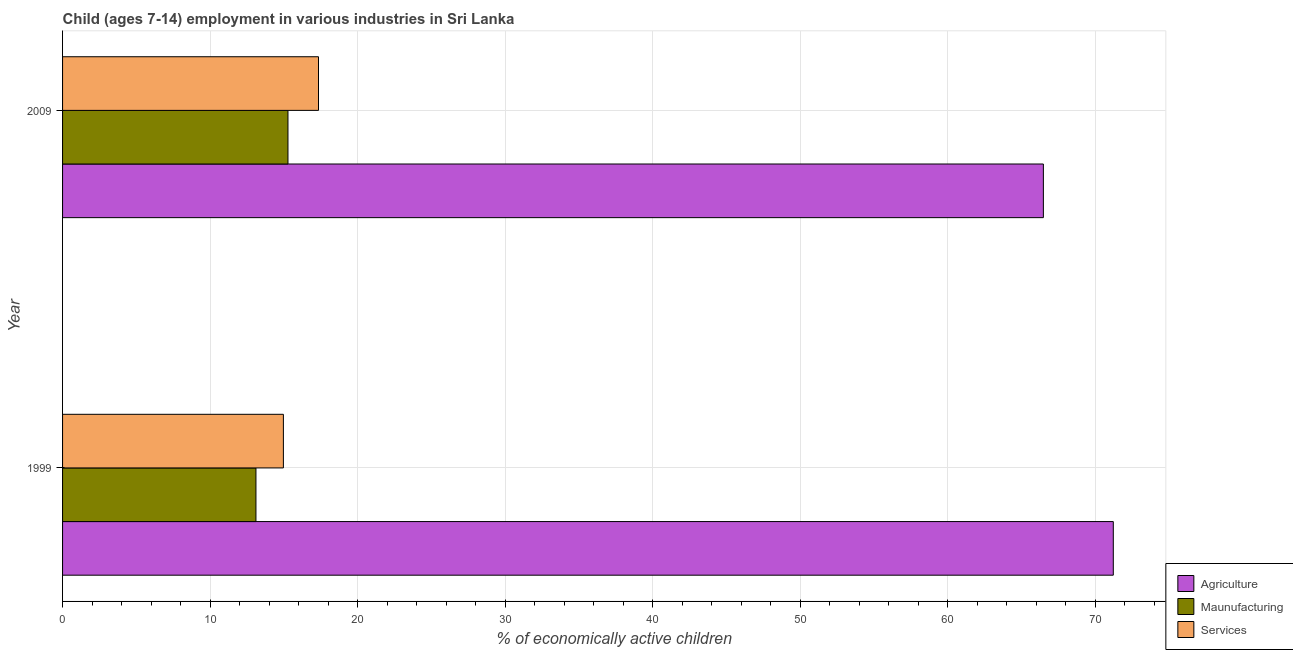Are the number of bars per tick equal to the number of legend labels?
Provide a short and direct response. Yes. How many bars are there on the 2nd tick from the top?
Keep it short and to the point. 3. What is the label of the 2nd group of bars from the top?
Your response must be concise. 1999. In how many cases, is the number of bars for a given year not equal to the number of legend labels?
Provide a short and direct response. 0. What is the percentage of economically active children in manufacturing in 1999?
Give a very brief answer. 13.11. Across all years, what is the maximum percentage of economically active children in agriculture?
Make the answer very short. 71.23. Across all years, what is the minimum percentage of economically active children in agriculture?
Provide a succinct answer. 66.49. In which year was the percentage of economically active children in agriculture minimum?
Offer a very short reply. 2009. What is the total percentage of economically active children in services in the graph?
Give a very brief answer. 32.32. What is the difference between the percentage of economically active children in agriculture in 1999 and that in 2009?
Your answer should be compact. 4.74. What is the difference between the percentage of economically active children in services in 2009 and the percentage of economically active children in agriculture in 1999?
Your answer should be very brief. -53.88. What is the average percentage of economically active children in manufacturing per year?
Your response must be concise. 14.2. In the year 2009, what is the difference between the percentage of economically active children in agriculture and percentage of economically active children in manufacturing?
Your answer should be compact. 51.21. What is the ratio of the percentage of economically active children in agriculture in 1999 to that in 2009?
Your answer should be very brief. 1.07. Is the difference between the percentage of economically active children in manufacturing in 1999 and 2009 greater than the difference between the percentage of economically active children in services in 1999 and 2009?
Offer a very short reply. Yes. In how many years, is the percentage of economically active children in manufacturing greater than the average percentage of economically active children in manufacturing taken over all years?
Make the answer very short. 1. What does the 3rd bar from the top in 1999 represents?
Ensure brevity in your answer.  Agriculture. What does the 3rd bar from the bottom in 1999 represents?
Provide a short and direct response. Services. How many years are there in the graph?
Give a very brief answer. 2. What is the difference between two consecutive major ticks on the X-axis?
Provide a short and direct response. 10. Are the values on the major ticks of X-axis written in scientific E-notation?
Provide a succinct answer. No. How are the legend labels stacked?
Give a very brief answer. Vertical. What is the title of the graph?
Give a very brief answer. Child (ages 7-14) employment in various industries in Sri Lanka. What is the label or title of the X-axis?
Keep it short and to the point. % of economically active children. What is the label or title of the Y-axis?
Provide a succinct answer. Year. What is the % of economically active children in Agriculture in 1999?
Ensure brevity in your answer.  71.23. What is the % of economically active children in Maunufacturing in 1999?
Keep it short and to the point. 13.11. What is the % of economically active children of Services in 1999?
Keep it short and to the point. 14.97. What is the % of economically active children in Agriculture in 2009?
Make the answer very short. 66.49. What is the % of economically active children in Maunufacturing in 2009?
Give a very brief answer. 15.28. What is the % of economically active children in Services in 2009?
Make the answer very short. 17.35. Across all years, what is the maximum % of economically active children in Agriculture?
Your answer should be compact. 71.23. Across all years, what is the maximum % of economically active children of Maunufacturing?
Make the answer very short. 15.28. Across all years, what is the maximum % of economically active children in Services?
Make the answer very short. 17.35. Across all years, what is the minimum % of economically active children of Agriculture?
Give a very brief answer. 66.49. Across all years, what is the minimum % of economically active children of Maunufacturing?
Your answer should be very brief. 13.11. Across all years, what is the minimum % of economically active children in Services?
Make the answer very short. 14.97. What is the total % of economically active children in Agriculture in the graph?
Your answer should be compact. 137.72. What is the total % of economically active children of Maunufacturing in the graph?
Provide a short and direct response. 28.39. What is the total % of economically active children of Services in the graph?
Keep it short and to the point. 32.32. What is the difference between the % of economically active children of Agriculture in 1999 and that in 2009?
Offer a terse response. 4.74. What is the difference between the % of economically active children in Maunufacturing in 1999 and that in 2009?
Keep it short and to the point. -2.17. What is the difference between the % of economically active children of Services in 1999 and that in 2009?
Keep it short and to the point. -2.38. What is the difference between the % of economically active children in Agriculture in 1999 and the % of economically active children in Maunufacturing in 2009?
Keep it short and to the point. 55.95. What is the difference between the % of economically active children in Agriculture in 1999 and the % of economically active children in Services in 2009?
Your answer should be compact. 53.88. What is the difference between the % of economically active children of Maunufacturing in 1999 and the % of economically active children of Services in 2009?
Keep it short and to the point. -4.24. What is the average % of economically active children in Agriculture per year?
Ensure brevity in your answer.  68.86. What is the average % of economically active children of Maunufacturing per year?
Offer a very short reply. 14.2. What is the average % of economically active children of Services per year?
Offer a terse response. 16.16. In the year 1999, what is the difference between the % of economically active children of Agriculture and % of economically active children of Maunufacturing?
Offer a very short reply. 58.12. In the year 1999, what is the difference between the % of economically active children of Agriculture and % of economically active children of Services?
Your answer should be very brief. 56.26. In the year 1999, what is the difference between the % of economically active children of Maunufacturing and % of economically active children of Services?
Provide a succinct answer. -1.86. In the year 2009, what is the difference between the % of economically active children in Agriculture and % of economically active children in Maunufacturing?
Your answer should be very brief. 51.21. In the year 2009, what is the difference between the % of economically active children of Agriculture and % of economically active children of Services?
Your answer should be compact. 49.14. In the year 2009, what is the difference between the % of economically active children of Maunufacturing and % of economically active children of Services?
Your answer should be compact. -2.07. What is the ratio of the % of economically active children of Agriculture in 1999 to that in 2009?
Offer a very short reply. 1.07. What is the ratio of the % of economically active children in Maunufacturing in 1999 to that in 2009?
Keep it short and to the point. 0.86. What is the ratio of the % of economically active children in Services in 1999 to that in 2009?
Your answer should be very brief. 0.86. What is the difference between the highest and the second highest % of economically active children of Agriculture?
Your response must be concise. 4.74. What is the difference between the highest and the second highest % of economically active children of Maunufacturing?
Provide a succinct answer. 2.17. What is the difference between the highest and the second highest % of economically active children of Services?
Provide a succinct answer. 2.38. What is the difference between the highest and the lowest % of economically active children of Agriculture?
Provide a short and direct response. 4.74. What is the difference between the highest and the lowest % of economically active children in Maunufacturing?
Your answer should be very brief. 2.17. What is the difference between the highest and the lowest % of economically active children in Services?
Your response must be concise. 2.38. 